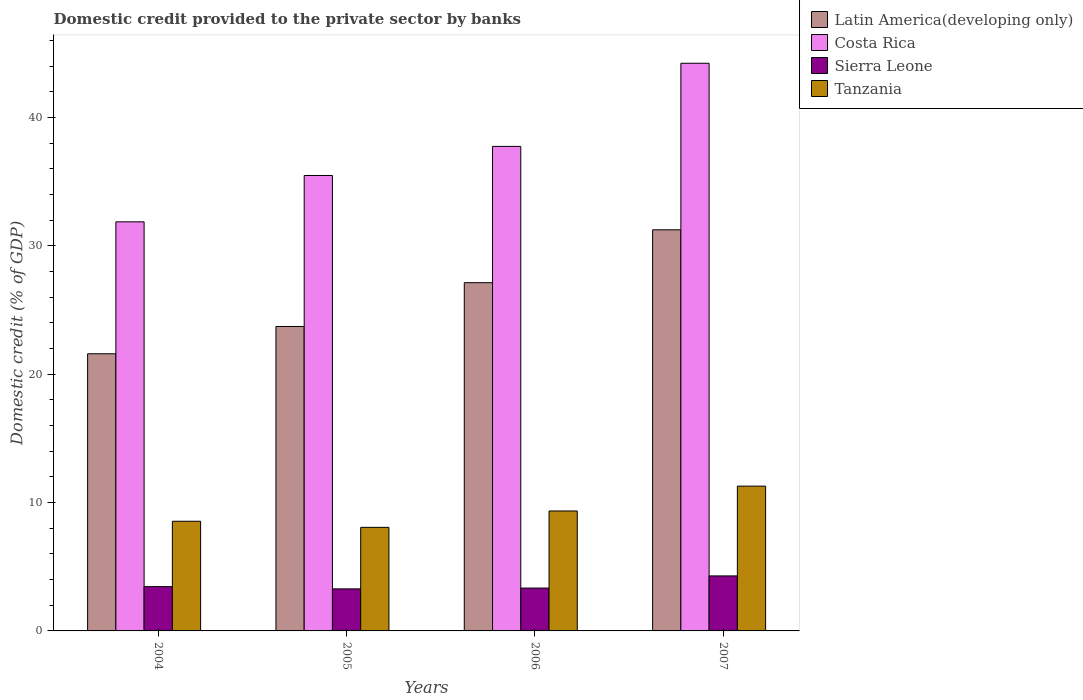Are the number of bars per tick equal to the number of legend labels?
Your answer should be compact. Yes. How many bars are there on the 1st tick from the right?
Offer a very short reply. 4. What is the label of the 3rd group of bars from the left?
Provide a succinct answer. 2006. What is the domestic credit provided to the private sector by banks in Latin America(developing only) in 2004?
Make the answer very short. 21.59. Across all years, what is the maximum domestic credit provided to the private sector by banks in Sierra Leone?
Offer a terse response. 4.28. Across all years, what is the minimum domestic credit provided to the private sector by banks in Tanzania?
Keep it short and to the point. 8.07. In which year was the domestic credit provided to the private sector by banks in Latin America(developing only) minimum?
Your answer should be very brief. 2004. What is the total domestic credit provided to the private sector by banks in Sierra Leone in the graph?
Offer a terse response. 14.35. What is the difference between the domestic credit provided to the private sector by banks in Latin America(developing only) in 2006 and that in 2007?
Make the answer very short. -4.12. What is the difference between the domestic credit provided to the private sector by banks in Tanzania in 2007 and the domestic credit provided to the private sector by banks in Sierra Leone in 2004?
Keep it short and to the point. 7.83. What is the average domestic credit provided to the private sector by banks in Sierra Leone per year?
Your answer should be very brief. 3.59. In the year 2006, what is the difference between the domestic credit provided to the private sector by banks in Latin America(developing only) and domestic credit provided to the private sector by banks in Sierra Leone?
Give a very brief answer. 23.79. In how many years, is the domestic credit provided to the private sector by banks in Sierra Leone greater than 32 %?
Offer a terse response. 0. What is the ratio of the domestic credit provided to the private sector by banks in Costa Rica in 2006 to that in 2007?
Your answer should be compact. 0.85. Is the domestic credit provided to the private sector by banks in Costa Rica in 2004 less than that in 2007?
Your response must be concise. Yes. What is the difference between the highest and the second highest domestic credit provided to the private sector by banks in Sierra Leone?
Give a very brief answer. 0.84. What is the difference between the highest and the lowest domestic credit provided to the private sector by banks in Costa Rica?
Your answer should be compact. 12.35. What does the 1st bar from the left in 2005 represents?
Provide a short and direct response. Latin America(developing only). What does the 1st bar from the right in 2006 represents?
Your answer should be very brief. Tanzania. Is it the case that in every year, the sum of the domestic credit provided to the private sector by banks in Costa Rica and domestic credit provided to the private sector by banks in Tanzania is greater than the domestic credit provided to the private sector by banks in Latin America(developing only)?
Give a very brief answer. Yes. How many bars are there?
Offer a very short reply. 16. How many years are there in the graph?
Your response must be concise. 4. Are the values on the major ticks of Y-axis written in scientific E-notation?
Give a very brief answer. No. Does the graph contain any zero values?
Ensure brevity in your answer.  No. How are the legend labels stacked?
Ensure brevity in your answer.  Vertical. What is the title of the graph?
Make the answer very short. Domestic credit provided to the private sector by banks. What is the label or title of the Y-axis?
Keep it short and to the point. Domestic credit (% of GDP). What is the Domestic credit (% of GDP) of Latin America(developing only) in 2004?
Offer a very short reply. 21.59. What is the Domestic credit (% of GDP) in Costa Rica in 2004?
Make the answer very short. 31.87. What is the Domestic credit (% of GDP) in Sierra Leone in 2004?
Offer a very short reply. 3.45. What is the Domestic credit (% of GDP) of Tanzania in 2004?
Your response must be concise. 8.54. What is the Domestic credit (% of GDP) of Latin America(developing only) in 2005?
Ensure brevity in your answer.  23.72. What is the Domestic credit (% of GDP) in Costa Rica in 2005?
Provide a succinct answer. 35.48. What is the Domestic credit (% of GDP) in Sierra Leone in 2005?
Keep it short and to the point. 3.28. What is the Domestic credit (% of GDP) in Tanzania in 2005?
Keep it short and to the point. 8.07. What is the Domestic credit (% of GDP) of Latin America(developing only) in 2006?
Your answer should be compact. 27.13. What is the Domestic credit (% of GDP) in Costa Rica in 2006?
Your response must be concise. 37.75. What is the Domestic credit (% of GDP) of Sierra Leone in 2006?
Keep it short and to the point. 3.34. What is the Domestic credit (% of GDP) of Tanzania in 2006?
Provide a short and direct response. 9.34. What is the Domestic credit (% of GDP) of Latin America(developing only) in 2007?
Ensure brevity in your answer.  31.25. What is the Domestic credit (% of GDP) in Costa Rica in 2007?
Your answer should be compact. 44.22. What is the Domestic credit (% of GDP) of Sierra Leone in 2007?
Your answer should be compact. 4.28. What is the Domestic credit (% of GDP) of Tanzania in 2007?
Ensure brevity in your answer.  11.28. Across all years, what is the maximum Domestic credit (% of GDP) in Latin America(developing only)?
Ensure brevity in your answer.  31.25. Across all years, what is the maximum Domestic credit (% of GDP) in Costa Rica?
Offer a terse response. 44.22. Across all years, what is the maximum Domestic credit (% of GDP) of Sierra Leone?
Provide a short and direct response. 4.28. Across all years, what is the maximum Domestic credit (% of GDP) in Tanzania?
Make the answer very short. 11.28. Across all years, what is the minimum Domestic credit (% of GDP) of Latin America(developing only)?
Your answer should be very brief. 21.59. Across all years, what is the minimum Domestic credit (% of GDP) in Costa Rica?
Provide a succinct answer. 31.87. Across all years, what is the minimum Domestic credit (% of GDP) of Sierra Leone?
Make the answer very short. 3.28. Across all years, what is the minimum Domestic credit (% of GDP) of Tanzania?
Offer a very short reply. 8.07. What is the total Domestic credit (% of GDP) in Latin America(developing only) in the graph?
Keep it short and to the point. 103.68. What is the total Domestic credit (% of GDP) of Costa Rica in the graph?
Provide a succinct answer. 149.32. What is the total Domestic credit (% of GDP) in Sierra Leone in the graph?
Your response must be concise. 14.35. What is the total Domestic credit (% of GDP) in Tanzania in the graph?
Give a very brief answer. 37.24. What is the difference between the Domestic credit (% of GDP) of Latin America(developing only) in 2004 and that in 2005?
Keep it short and to the point. -2.13. What is the difference between the Domestic credit (% of GDP) of Costa Rica in 2004 and that in 2005?
Offer a terse response. -3.61. What is the difference between the Domestic credit (% of GDP) in Sierra Leone in 2004 and that in 2005?
Keep it short and to the point. 0.17. What is the difference between the Domestic credit (% of GDP) of Tanzania in 2004 and that in 2005?
Give a very brief answer. 0.47. What is the difference between the Domestic credit (% of GDP) in Latin America(developing only) in 2004 and that in 2006?
Offer a very short reply. -5.54. What is the difference between the Domestic credit (% of GDP) of Costa Rica in 2004 and that in 2006?
Keep it short and to the point. -5.88. What is the difference between the Domestic credit (% of GDP) in Sierra Leone in 2004 and that in 2006?
Offer a very short reply. 0.11. What is the difference between the Domestic credit (% of GDP) in Tanzania in 2004 and that in 2006?
Your answer should be very brief. -0.8. What is the difference between the Domestic credit (% of GDP) of Latin America(developing only) in 2004 and that in 2007?
Provide a short and direct response. -9.66. What is the difference between the Domestic credit (% of GDP) of Costa Rica in 2004 and that in 2007?
Your answer should be compact. -12.35. What is the difference between the Domestic credit (% of GDP) in Sierra Leone in 2004 and that in 2007?
Offer a very short reply. -0.84. What is the difference between the Domestic credit (% of GDP) in Tanzania in 2004 and that in 2007?
Provide a succinct answer. -2.74. What is the difference between the Domestic credit (% of GDP) in Latin America(developing only) in 2005 and that in 2006?
Give a very brief answer. -3.41. What is the difference between the Domestic credit (% of GDP) in Costa Rica in 2005 and that in 2006?
Provide a succinct answer. -2.27. What is the difference between the Domestic credit (% of GDP) of Sierra Leone in 2005 and that in 2006?
Offer a terse response. -0.06. What is the difference between the Domestic credit (% of GDP) in Tanzania in 2005 and that in 2006?
Make the answer very short. -1.28. What is the difference between the Domestic credit (% of GDP) of Latin America(developing only) in 2005 and that in 2007?
Your response must be concise. -7.53. What is the difference between the Domestic credit (% of GDP) of Costa Rica in 2005 and that in 2007?
Make the answer very short. -8.74. What is the difference between the Domestic credit (% of GDP) in Sierra Leone in 2005 and that in 2007?
Your answer should be very brief. -1.01. What is the difference between the Domestic credit (% of GDP) in Tanzania in 2005 and that in 2007?
Offer a very short reply. -3.21. What is the difference between the Domestic credit (% of GDP) of Latin America(developing only) in 2006 and that in 2007?
Offer a very short reply. -4.12. What is the difference between the Domestic credit (% of GDP) in Costa Rica in 2006 and that in 2007?
Provide a short and direct response. -6.48. What is the difference between the Domestic credit (% of GDP) of Sierra Leone in 2006 and that in 2007?
Your answer should be compact. -0.95. What is the difference between the Domestic credit (% of GDP) in Tanzania in 2006 and that in 2007?
Offer a terse response. -1.94. What is the difference between the Domestic credit (% of GDP) in Latin America(developing only) in 2004 and the Domestic credit (% of GDP) in Costa Rica in 2005?
Your answer should be compact. -13.89. What is the difference between the Domestic credit (% of GDP) of Latin America(developing only) in 2004 and the Domestic credit (% of GDP) of Sierra Leone in 2005?
Provide a short and direct response. 18.32. What is the difference between the Domestic credit (% of GDP) in Latin America(developing only) in 2004 and the Domestic credit (% of GDP) in Tanzania in 2005?
Offer a terse response. 13.52. What is the difference between the Domestic credit (% of GDP) of Costa Rica in 2004 and the Domestic credit (% of GDP) of Sierra Leone in 2005?
Provide a short and direct response. 28.59. What is the difference between the Domestic credit (% of GDP) of Costa Rica in 2004 and the Domestic credit (% of GDP) of Tanzania in 2005?
Your answer should be very brief. 23.8. What is the difference between the Domestic credit (% of GDP) of Sierra Leone in 2004 and the Domestic credit (% of GDP) of Tanzania in 2005?
Offer a terse response. -4.62. What is the difference between the Domestic credit (% of GDP) of Latin America(developing only) in 2004 and the Domestic credit (% of GDP) of Costa Rica in 2006?
Provide a short and direct response. -16.16. What is the difference between the Domestic credit (% of GDP) in Latin America(developing only) in 2004 and the Domestic credit (% of GDP) in Sierra Leone in 2006?
Ensure brevity in your answer.  18.25. What is the difference between the Domestic credit (% of GDP) in Latin America(developing only) in 2004 and the Domestic credit (% of GDP) in Tanzania in 2006?
Keep it short and to the point. 12.25. What is the difference between the Domestic credit (% of GDP) of Costa Rica in 2004 and the Domestic credit (% of GDP) of Sierra Leone in 2006?
Offer a terse response. 28.53. What is the difference between the Domestic credit (% of GDP) of Costa Rica in 2004 and the Domestic credit (% of GDP) of Tanzania in 2006?
Keep it short and to the point. 22.52. What is the difference between the Domestic credit (% of GDP) of Sierra Leone in 2004 and the Domestic credit (% of GDP) of Tanzania in 2006?
Give a very brief answer. -5.89. What is the difference between the Domestic credit (% of GDP) of Latin America(developing only) in 2004 and the Domestic credit (% of GDP) of Costa Rica in 2007?
Provide a short and direct response. -22.63. What is the difference between the Domestic credit (% of GDP) of Latin America(developing only) in 2004 and the Domestic credit (% of GDP) of Sierra Leone in 2007?
Provide a succinct answer. 17.31. What is the difference between the Domestic credit (% of GDP) of Latin America(developing only) in 2004 and the Domestic credit (% of GDP) of Tanzania in 2007?
Your response must be concise. 10.31. What is the difference between the Domestic credit (% of GDP) in Costa Rica in 2004 and the Domestic credit (% of GDP) in Sierra Leone in 2007?
Provide a succinct answer. 27.58. What is the difference between the Domestic credit (% of GDP) in Costa Rica in 2004 and the Domestic credit (% of GDP) in Tanzania in 2007?
Ensure brevity in your answer.  20.59. What is the difference between the Domestic credit (% of GDP) of Sierra Leone in 2004 and the Domestic credit (% of GDP) of Tanzania in 2007?
Keep it short and to the point. -7.83. What is the difference between the Domestic credit (% of GDP) of Latin America(developing only) in 2005 and the Domestic credit (% of GDP) of Costa Rica in 2006?
Your answer should be compact. -14.03. What is the difference between the Domestic credit (% of GDP) of Latin America(developing only) in 2005 and the Domestic credit (% of GDP) of Sierra Leone in 2006?
Provide a short and direct response. 20.38. What is the difference between the Domestic credit (% of GDP) of Latin America(developing only) in 2005 and the Domestic credit (% of GDP) of Tanzania in 2006?
Your answer should be compact. 14.37. What is the difference between the Domestic credit (% of GDP) in Costa Rica in 2005 and the Domestic credit (% of GDP) in Sierra Leone in 2006?
Make the answer very short. 32.14. What is the difference between the Domestic credit (% of GDP) of Costa Rica in 2005 and the Domestic credit (% of GDP) of Tanzania in 2006?
Ensure brevity in your answer.  26.13. What is the difference between the Domestic credit (% of GDP) of Sierra Leone in 2005 and the Domestic credit (% of GDP) of Tanzania in 2006?
Give a very brief answer. -6.07. What is the difference between the Domestic credit (% of GDP) in Latin America(developing only) in 2005 and the Domestic credit (% of GDP) in Costa Rica in 2007?
Offer a terse response. -20.5. What is the difference between the Domestic credit (% of GDP) of Latin America(developing only) in 2005 and the Domestic credit (% of GDP) of Sierra Leone in 2007?
Give a very brief answer. 19.43. What is the difference between the Domestic credit (% of GDP) in Latin America(developing only) in 2005 and the Domestic credit (% of GDP) in Tanzania in 2007?
Ensure brevity in your answer.  12.44. What is the difference between the Domestic credit (% of GDP) in Costa Rica in 2005 and the Domestic credit (% of GDP) in Sierra Leone in 2007?
Ensure brevity in your answer.  31.19. What is the difference between the Domestic credit (% of GDP) in Costa Rica in 2005 and the Domestic credit (% of GDP) in Tanzania in 2007?
Provide a short and direct response. 24.2. What is the difference between the Domestic credit (% of GDP) of Sierra Leone in 2005 and the Domestic credit (% of GDP) of Tanzania in 2007?
Ensure brevity in your answer.  -8. What is the difference between the Domestic credit (% of GDP) of Latin America(developing only) in 2006 and the Domestic credit (% of GDP) of Costa Rica in 2007?
Your answer should be very brief. -17.09. What is the difference between the Domestic credit (% of GDP) of Latin America(developing only) in 2006 and the Domestic credit (% of GDP) of Sierra Leone in 2007?
Keep it short and to the point. 22.84. What is the difference between the Domestic credit (% of GDP) of Latin America(developing only) in 2006 and the Domestic credit (% of GDP) of Tanzania in 2007?
Your response must be concise. 15.85. What is the difference between the Domestic credit (% of GDP) in Costa Rica in 2006 and the Domestic credit (% of GDP) in Sierra Leone in 2007?
Ensure brevity in your answer.  33.46. What is the difference between the Domestic credit (% of GDP) of Costa Rica in 2006 and the Domestic credit (% of GDP) of Tanzania in 2007?
Provide a succinct answer. 26.47. What is the difference between the Domestic credit (% of GDP) of Sierra Leone in 2006 and the Domestic credit (% of GDP) of Tanzania in 2007?
Your answer should be compact. -7.94. What is the average Domestic credit (% of GDP) of Latin America(developing only) per year?
Offer a terse response. 25.92. What is the average Domestic credit (% of GDP) in Costa Rica per year?
Keep it short and to the point. 37.33. What is the average Domestic credit (% of GDP) of Sierra Leone per year?
Offer a terse response. 3.59. What is the average Domestic credit (% of GDP) of Tanzania per year?
Give a very brief answer. 9.31. In the year 2004, what is the difference between the Domestic credit (% of GDP) of Latin America(developing only) and Domestic credit (% of GDP) of Costa Rica?
Provide a succinct answer. -10.28. In the year 2004, what is the difference between the Domestic credit (% of GDP) of Latin America(developing only) and Domestic credit (% of GDP) of Sierra Leone?
Provide a short and direct response. 18.14. In the year 2004, what is the difference between the Domestic credit (% of GDP) of Latin America(developing only) and Domestic credit (% of GDP) of Tanzania?
Give a very brief answer. 13.05. In the year 2004, what is the difference between the Domestic credit (% of GDP) in Costa Rica and Domestic credit (% of GDP) in Sierra Leone?
Offer a terse response. 28.42. In the year 2004, what is the difference between the Domestic credit (% of GDP) of Costa Rica and Domestic credit (% of GDP) of Tanzania?
Offer a very short reply. 23.33. In the year 2004, what is the difference between the Domestic credit (% of GDP) of Sierra Leone and Domestic credit (% of GDP) of Tanzania?
Offer a very short reply. -5.09. In the year 2005, what is the difference between the Domestic credit (% of GDP) of Latin America(developing only) and Domestic credit (% of GDP) of Costa Rica?
Give a very brief answer. -11.76. In the year 2005, what is the difference between the Domestic credit (% of GDP) in Latin America(developing only) and Domestic credit (% of GDP) in Sierra Leone?
Provide a short and direct response. 20.44. In the year 2005, what is the difference between the Domestic credit (% of GDP) in Latin America(developing only) and Domestic credit (% of GDP) in Tanzania?
Make the answer very short. 15.65. In the year 2005, what is the difference between the Domestic credit (% of GDP) in Costa Rica and Domestic credit (% of GDP) in Sierra Leone?
Ensure brevity in your answer.  32.2. In the year 2005, what is the difference between the Domestic credit (% of GDP) of Costa Rica and Domestic credit (% of GDP) of Tanzania?
Your answer should be very brief. 27.41. In the year 2005, what is the difference between the Domestic credit (% of GDP) in Sierra Leone and Domestic credit (% of GDP) in Tanzania?
Ensure brevity in your answer.  -4.79. In the year 2006, what is the difference between the Domestic credit (% of GDP) in Latin America(developing only) and Domestic credit (% of GDP) in Costa Rica?
Make the answer very short. -10.62. In the year 2006, what is the difference between the Domestic credit (% of GDP) in Latin America(developing only) and Domestic credit (% of GDP) in Sierra Leone?
Your answer should be compact. 23.79. In the year 2006, what is the difference between the Domestic credit (% of GDP) of Latin America(developing only) and Domestic credit (% of GDP) of Tanzania?
Provide a short and direct response. 17.79. In the year 2006, what is the difference between the Domestic credit (% of GDP) of Costa Rica and Domestic credit (% of GDP) of Sierra Leone?
Keep it short and to the point. 34.41. In the year 2006, what is the difference between the Domestic credit (% of GDP) in Costa Rica and Domestic credit (% of GDP) in Tanzania?
Your answer should be very brief. 28.4. In the year 2006, what is the difference between the Domestic credit (% of GDP) of Sierra Leone and Domestic credit (% of GDP) of Tanzania?
Offer a very short reply. -6.01. In the year 2007, what is the difference between the Domestic credit (% of GDP) in Latin America(developing only) and Domestic credit (% of GDP) in Costa Rica?
Provide a succinct answer. -12.97. In the year 2007, what is the difference between the Domestic credit (% of GDP) of Latin America(developing only) and Domestic credit (% of GDP) of Sierra Leone?
Your response must be concise. 26.96. In the year 2007, what is the difference between the Domestic credit (% of GDP) of Latin America(developing only) and Domestic credit (% of GDP) of Tanzania?
Offer a terse response. 19.97. In the year 2007, what is the difference between the Domestic credit (% of GDP) in Costa Rica and Domestic credit (% of GDP) in Sierra Leone?
Ensure brevity in your answer.  39.94. In the year 2007, what is the difference between the Domestic credit (% of GDP) of Costa Rica and Domestic credit (% of GDP) of Tanzania?
Your response must be concise. 32.94. In the year 2007, what is the difference between the Domestic credit (% of GDP) of Sierra Leone and Domestic credit (% of GDP) of Tanzania?
Give a very brief answer. -7. What is the ratio of the Domestic credit (% of GDP) of Latin America(developing only) in 2004 to that in 2005?
Make the answer very short. 0.91. What is the ratio of the Domestic credit (% of GDP) of Costa Rica in 2004 to that in 2005?
Your answer should be very brief. 0.9. What is the ratio of the Domestic credit (% of GDP) of Sierra Leone in 2004 to that in 2005?
Keep it short and to the point. 1.05. What is the ratio of the Domestic credit (% of GDP) of Tanzania in 2004 to that in 2005?
Provide a short and direct response. 1.06. What is the ratio of the Domestic credit (% of GDP) in Latin America(developing only) in 2004 to that in 2006?
Offer a very short reply. 0.8. What is the ratio of the Domestic credit (% of GDP) in Costa Rica in 2004 to that in 2006?
Ensure brevity in your answer.  0.84. What is the ratio of the Domestic credit (% of GDP) in Sierra Leone in 2004 to that in 2006?
Offer a very short reply. 1.03. What is the ratio of the Domestic credit (% of GDP) in Tanzania in 2004 to that in 2006?
Offer a terse response. 0.91. What is the ratio of the Domestic credit (% of GDP) in Latin America(developing only) in 2004 to that in 2007?
Offer a terse response. 0.69. What is the ratio of the Domestic credit (% of GDP) in Costa Rica in 2004 to that in 2007?
Give a very brief answer. 0.72. What is the ratio of the Domestic credit (% of GDP) in Sierra Leone in 2004 to that in 2007?
Provide a short and direct response. 0.81. What is the ratio of the Domestic credit (% of GDP) of Tanzania in 2004 to that in 2007?
Offer a terse response. 0.76. What is the ratio of the Domestic credit (% of GDP) in Latin America(developing only) in 2005 to that in 2006?
Give a very brief answer. 0.87. What is the ratio of the Domestic credit (% of GDP) of Costa Rica in 2005 to that in 2006?
Provide a succinct answer. 0.94. What is the ratio of the Domestic credit (% of GDP) of Tanzania in 2005 to that in 2006?
Offer a very short reply. 0.86. What is the ratio of the Domestic credit (% of GDP) of Latin America(developing only) in 2005 to that in 2007?
Offer a very short reply. 0.76. What is the ratio of the Domestic credit (% of GDP) of Costa Rica in 2005 to that in 2007?
Your answer should be very brief. 0.8. What is the ratio of the Domestic credit (% of GDP) of Sierra Leone in 2005 to that in 2007?
Your response must be concise. 0.76. What is the ratio of the Domestic credit (% of GDP) of Tanzania in 2005 to that in 2007?
Your answer should be compact. 0.72. What is the ratio of the Domestic credit (% of GDP) of Latin America(developing only) in 2006 to that in 2007?
Your response must be concise. 0.87. What is the ratio of the Domestic credit (% of GDP) in Costa Rica in 2006 to that in 2007?
Provide a short and direct response. 0.85. What is the ratio of the Domestic credit (% of GDP) in Sierra Leone in 2006 to that in 2007?
Give a very brief answer. 0.78. What is the ratio of the Domestic credit (% of GDP) of Tanzania in 2006 to that in 2007?
Your response must be concise. 0.83. What is the difference between the highest and the second highest Domestic credit (% of GDP) in Latin America(developing only)?
Provide a short and direct response. 4.12. What is the difference between the highest and the second highest Domestic credit (% of GDP) of Costa Rica?
Ensure brevity in your answer.  6.48. What is the difference between the highest and the second highest Domestic credit (% of GDP) of Sierra Leone?
Provide a succinct answer. 0.84. What is the difference between the highest and the second highest Domestic credit (% of GDP) of Tanzania?
Your answer should be very brief. 1.94. What is the difference between the highest and the lowest Domestic credit (% of GDP) of Latin America(developing only)?
Offer a terse response. 9.66. What is the difference between the highest and the lowest Domestic credit (% of GDP) of Costa Rica?
Make the answer very short. 12.35. What is the difference between the highest and the lowest Domestic credit (% of GDP) in Sierra Leone?
Keep it short and to the point. 1.01. What is the difference between the highest and the lowest Domestic credit (% of GDP) in Tanzania?
Offer a terse response. 3.21. 